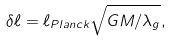Convert formula to latex. <formula><loc_0><loc_0><loc_500><loc_500>\delta \ell = \ell _ { P l a n c k } \sqrt { G M / \lambda _ { g } } ,</formula> 